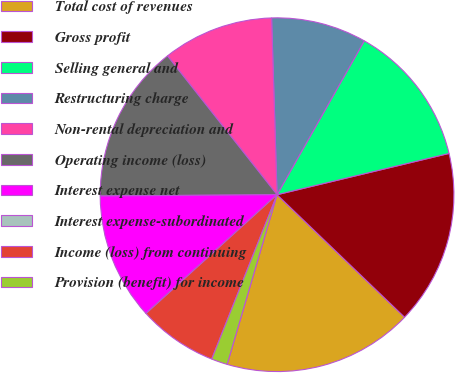Convert chart to OTSL. <chart><loc_0><loc_0><loc_500><loc_500><pie_chart><fcel>Total cost of revenues<fcel>Gross profit<fcel>Selling general and<fcel>Restructuring charge<fcel>Non-rental depreciation and<fcel>Operating income (loss)<fcel>Interest expense net<fcel>Interest expense-subordinated<fcel>Income (loss) from continuing<fcel>Provision (benefit) for income<nl><fcel>17.37%<fcel>15.93%<fcel>13.04%<fcel>8.7%<fcel>10.14%<fcel>14.48%<fcel>11.59%<fcel>0.02%<fcel>7.25%<fcel>1.47%<nl></chart> 